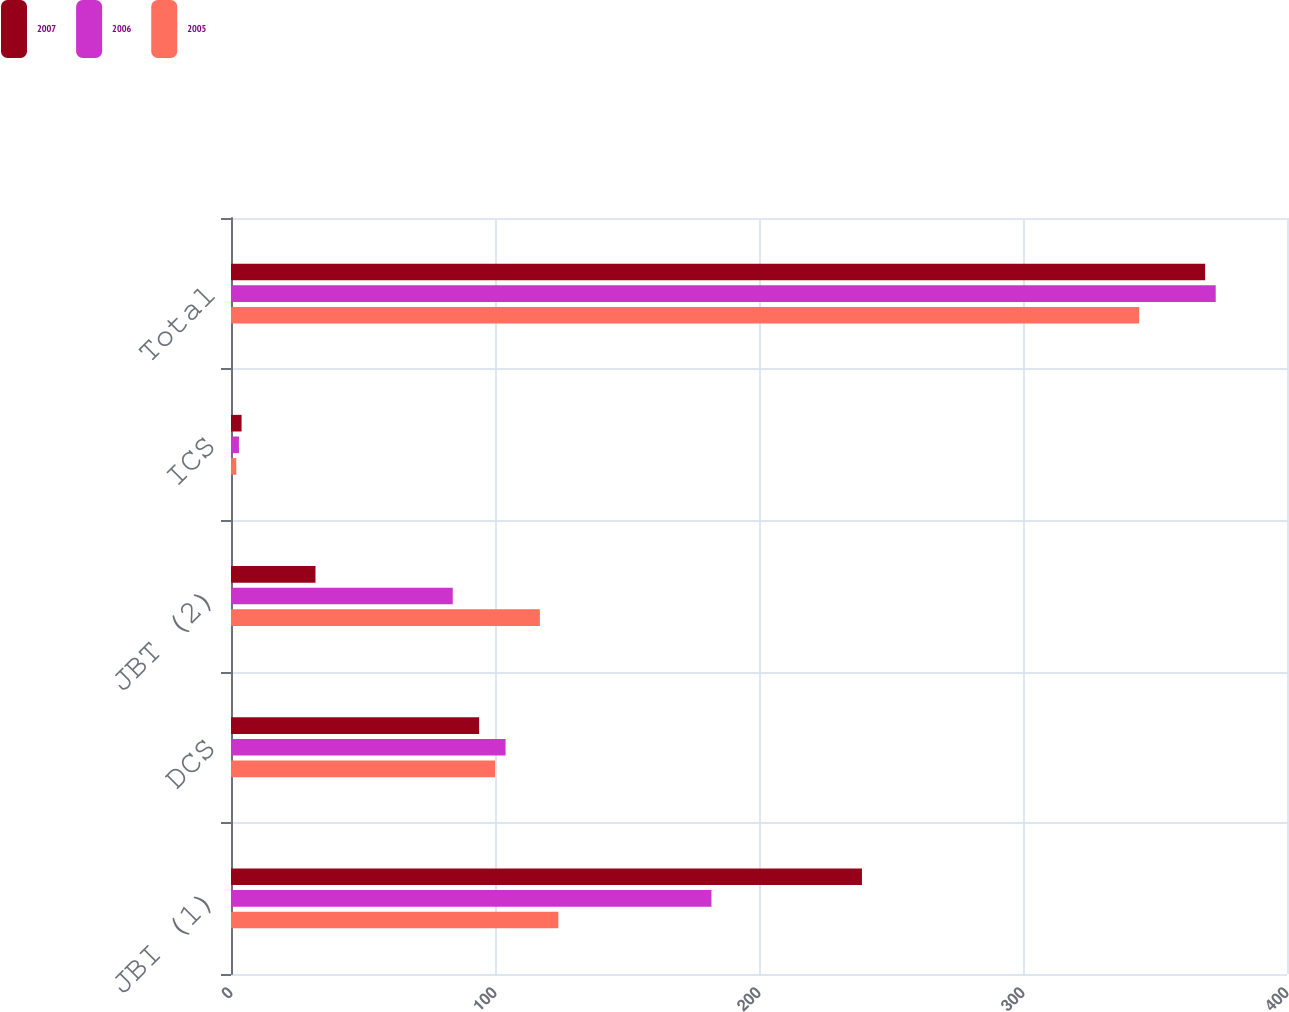Convert chart to OTSL. <chart><loc_0><loc_0><loc_500><loc_500><stacked_bar_chart><ecel><fcel>JBI (1)<fcel>DCS<fcel>JBT (2)<fcel>ICS<fcel>Total<nl><fcel>2007<fcel>239<fcel>94<fcel>32<fcel>4<fcel>369<nl><fcel>2006<fcel>182<fcel>104<fcel>84<fcel>3<fcel>373<nl><fcel>2005<fcel>124<fcel>100<fcel>117<fcel>2<fcel>344<nl></chart> 